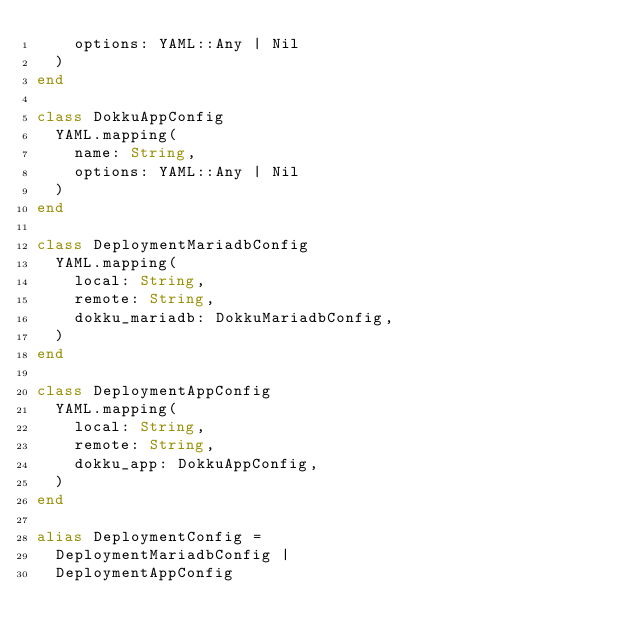<code> <loc_0><loc_0><loc_500><loc_500><_Crystal_>    options: YAML::Any | Nil
  )
end

class DokkuAppConfig
  YAML.mapping(
    name: String,
    options: YAML::Any | Nil
  )
end

class DeploymentMariadbConfig
  YAML.mapping(
    local: String,
    remote: String,
    dokku_mariadb: DokkuMariadbConfig,
  )
end

class DeploymentAppConfig
  YAML.mapping(
    local: String,
    remote: String,
    dokku_app: DokkuAppConfig,
  )
end

alias DeploymentConfig = 
  DeploymentMariadbConfig | 
  DeploymentAppConfig

</code> 